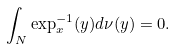Convert formula to latex. <formula><loc_0><loc_0><loc_500><loc_500>\int _ { N } \exp ^ { - 1 } _ { x } ( y ) d \nu ( y ) = 0 .</formula> 